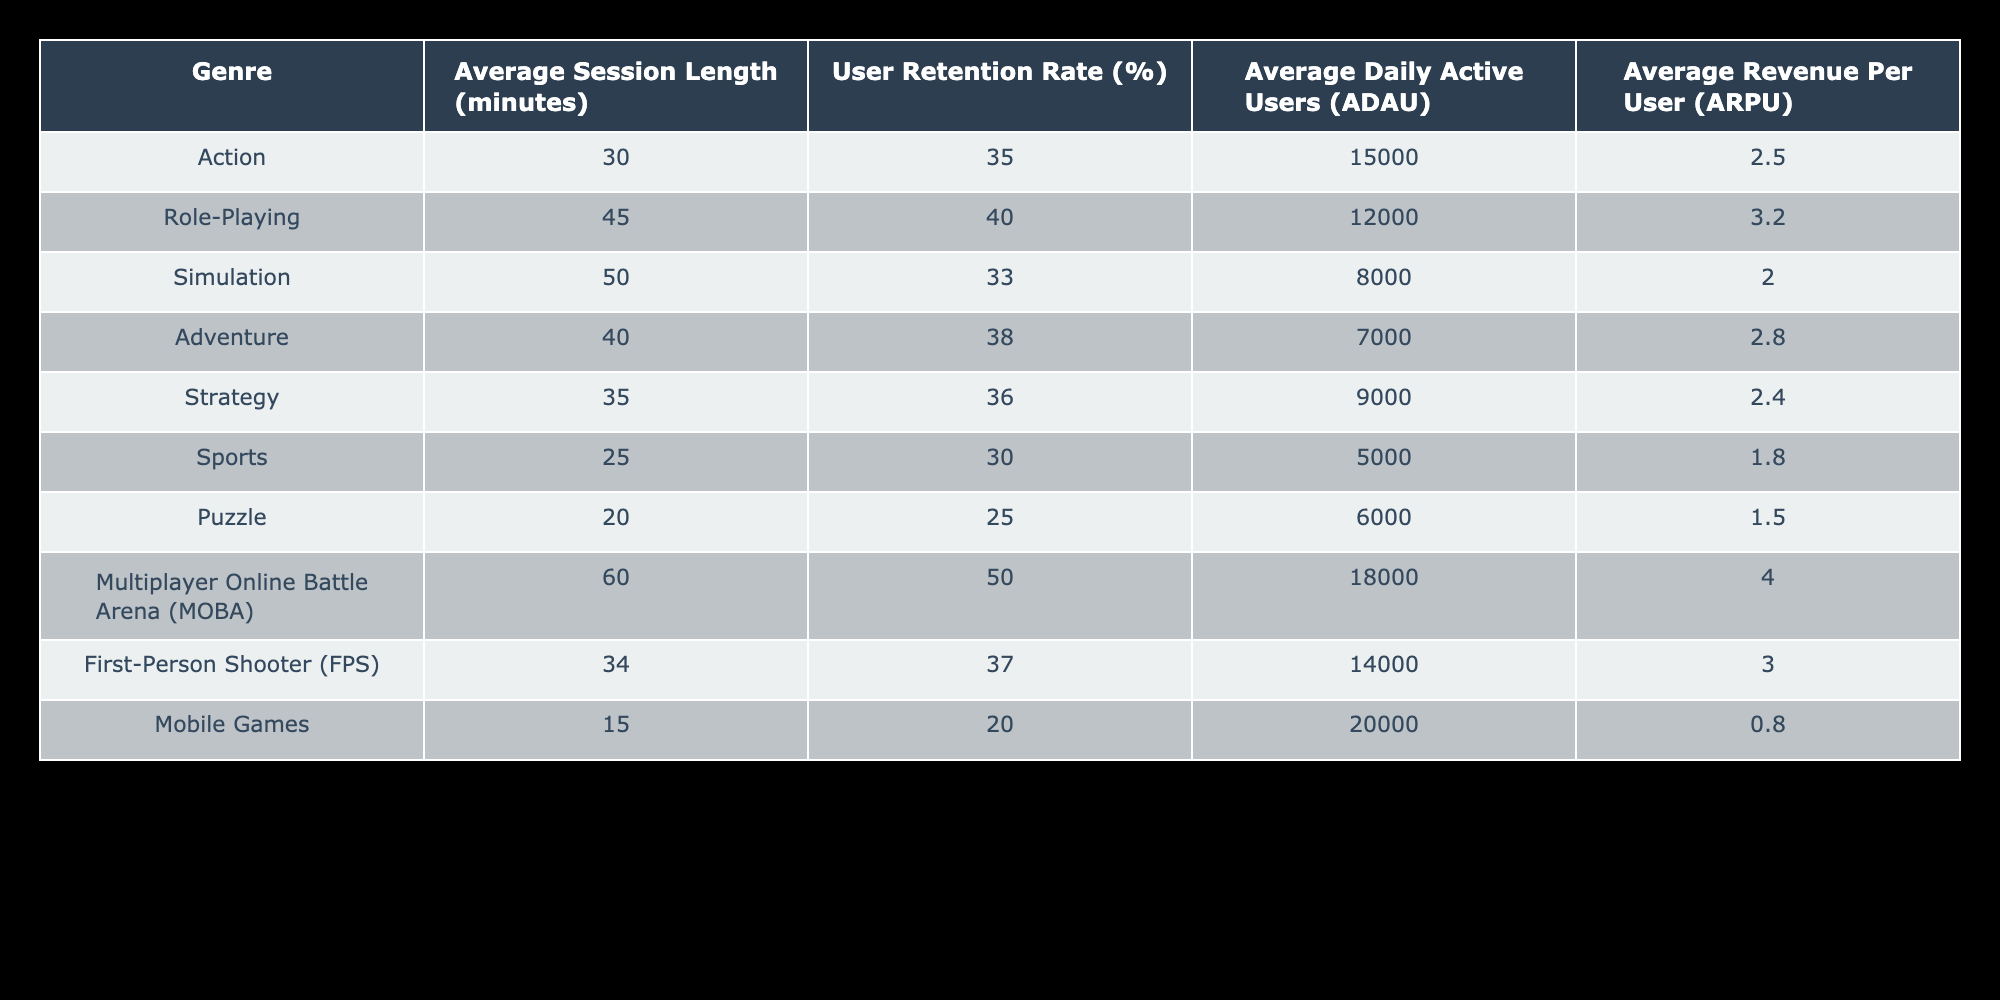What is the Average Session Length for the Puzzle genre? The table directly states the Average Session Length for the Puzzle genre is 20 minutes.
Answer: 20 minutes Which genre has the highest User Retention Rate? The highest User Retention Rate is found in the Multiplayer Online Battle Arena (MOBA) genre with a rate of 50%.
Answer: 50% What is the Average Daily Active Users (ADAU) for Strategy games compared to Adventure games? The Average Daily Active Users for Strategy games is 9000, while for Adventure games, it is 7000. Thus, Strategy games have 2000 more ADAU than Adventure games.
Answer: Strategy games have 2000 more ADAU Is the Average Revenue Per User (ARPU) for Mobile Games greater than that for Sports games? The ARPU for Mobile Games is 0.80, and for Sports games, it is 1.80. Therefore, the statement is false since 0.80 is less than 1.80.
Answer: No What is the difference in Average Session Length between Role-Playing and Action genres? The Average Session Length for Role-Playing games is 45 minutes and for Action games is 30 minutes. The difference is 45 - 30 = 15 minutes.
Answer: 15 minutes Which genres have an Average Revenue Per User (ARPU) higher than 2.50? The genres that have ARPU higher than 2.50 are Role-Playing (3.20), Multiplayer Online Battle Arena (4.00), and First-Person Shooter (3.00).
Answer: Role-Playing, MOBA, FPS If you add the Average Daily Active Users (ADAU) for Simulation and Puzzle genres, what is the total? The ADAU for Simulation is 8000 and for Puzzle is 6000. Adding them together gives 8000 + 6000 = 14000 total ADAU.
Answer: 14000 Is the Average Session Length for Sports genre less than 30 minutes? The Average Session Length for Sports genre is 25 minutes, which is less than 30 minutes. Thus, the answer is true.
Answer: Yes How does the User Retention Rate for FPS compare with that of Sports? The User Retention Rate for FPS is 37%, while for Sports, it is 30%. Therefore, FPS has a higher retention rate by 7%.
Answer: FPS has a higher retention rate by 7% 